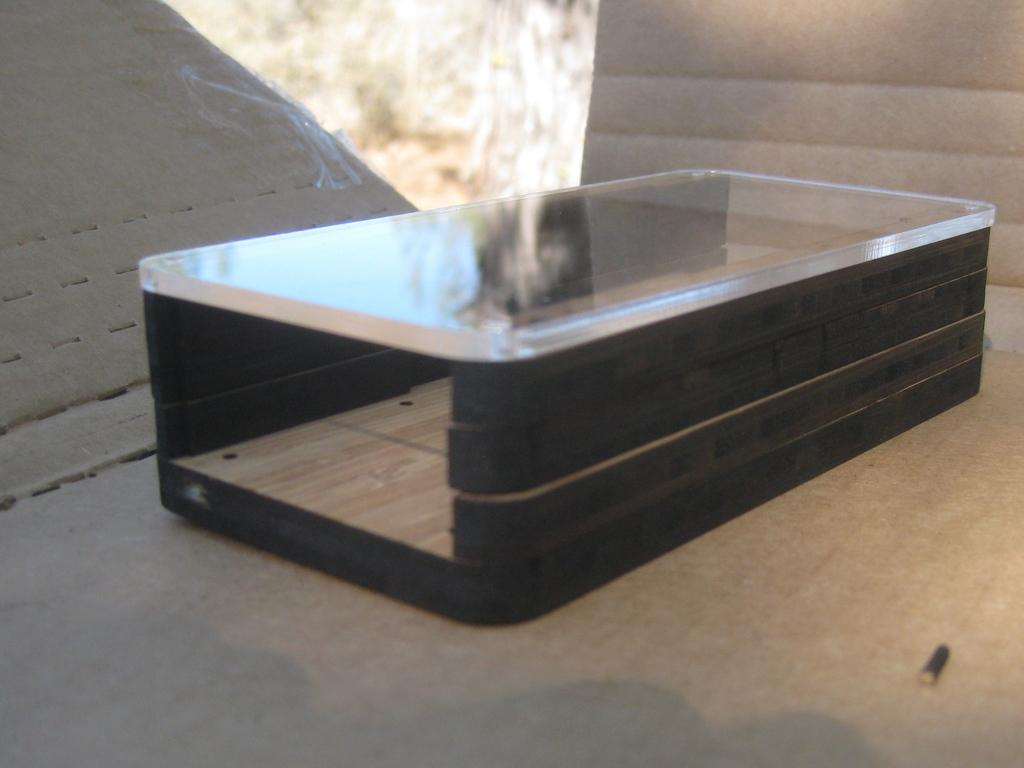What object is present in the image that has a screw in it? There is a cardboard box in the image that has a screw in it. What can be seen in the background of the image? Trees are visible at the back of the image. What is the reflection on the box in the image? There is a reflection of the sky on the box. What type of shoes can be seen on the roof in the image? There is no roof or shoes present in the image. 